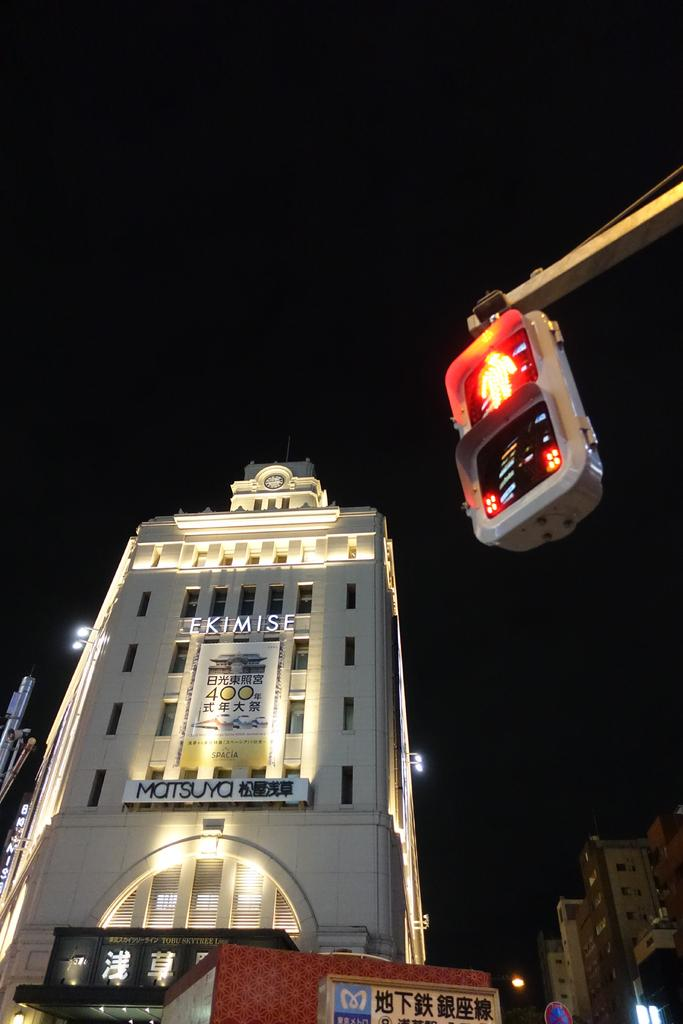<image>
Give a short and clear explanation of the subsequent image. A red pedestrian light at night across from the Ekimise building. 